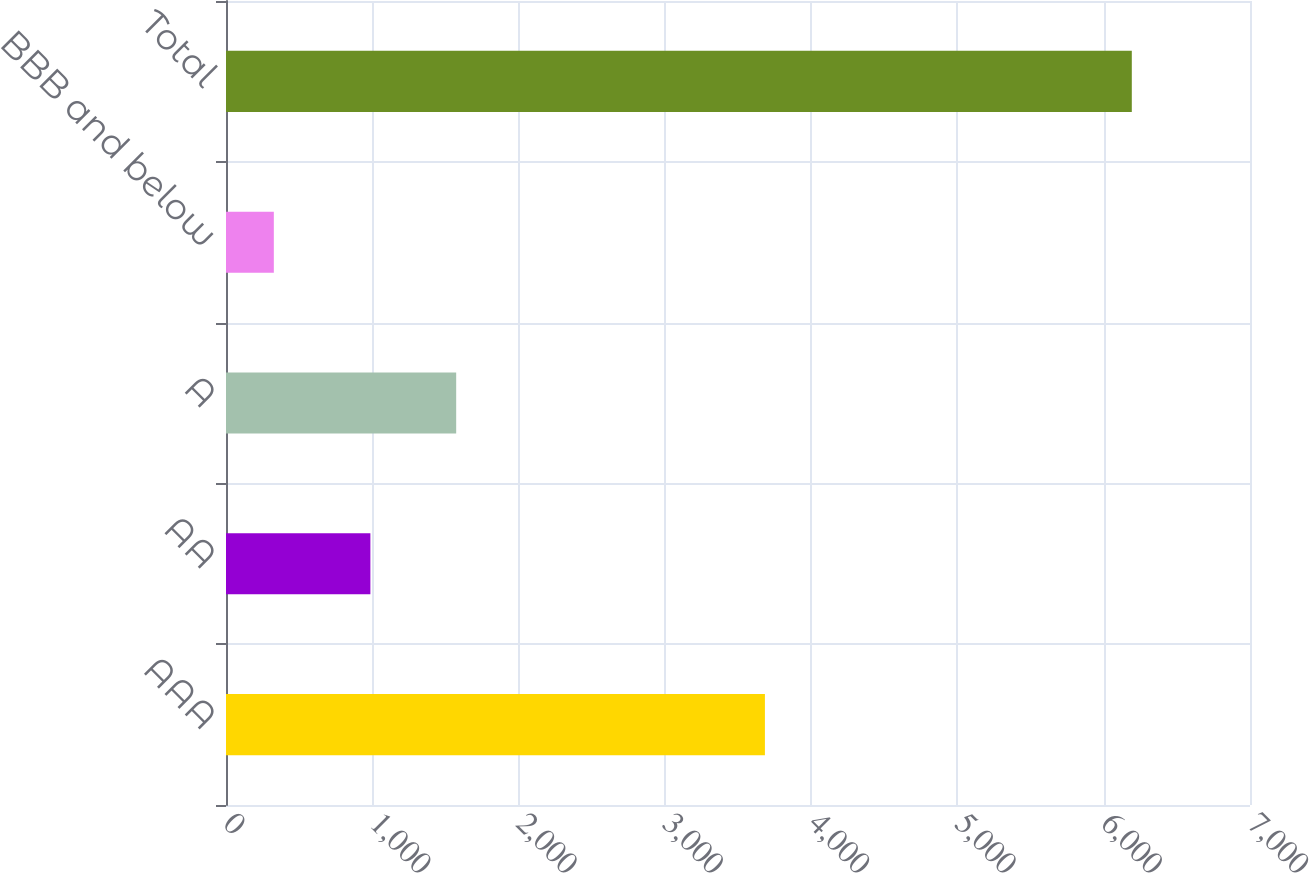<chart> <loc_0><loc_0><loc_500><loc_500><bar_chart><fcel>AAA<fcel>AA<fcel>A<fcel>BBB and below<fcel>Total<nl><fcel>3684<fcel>987<fcel>1573.5<fcel>327<fcel>6192<nl></chart> 